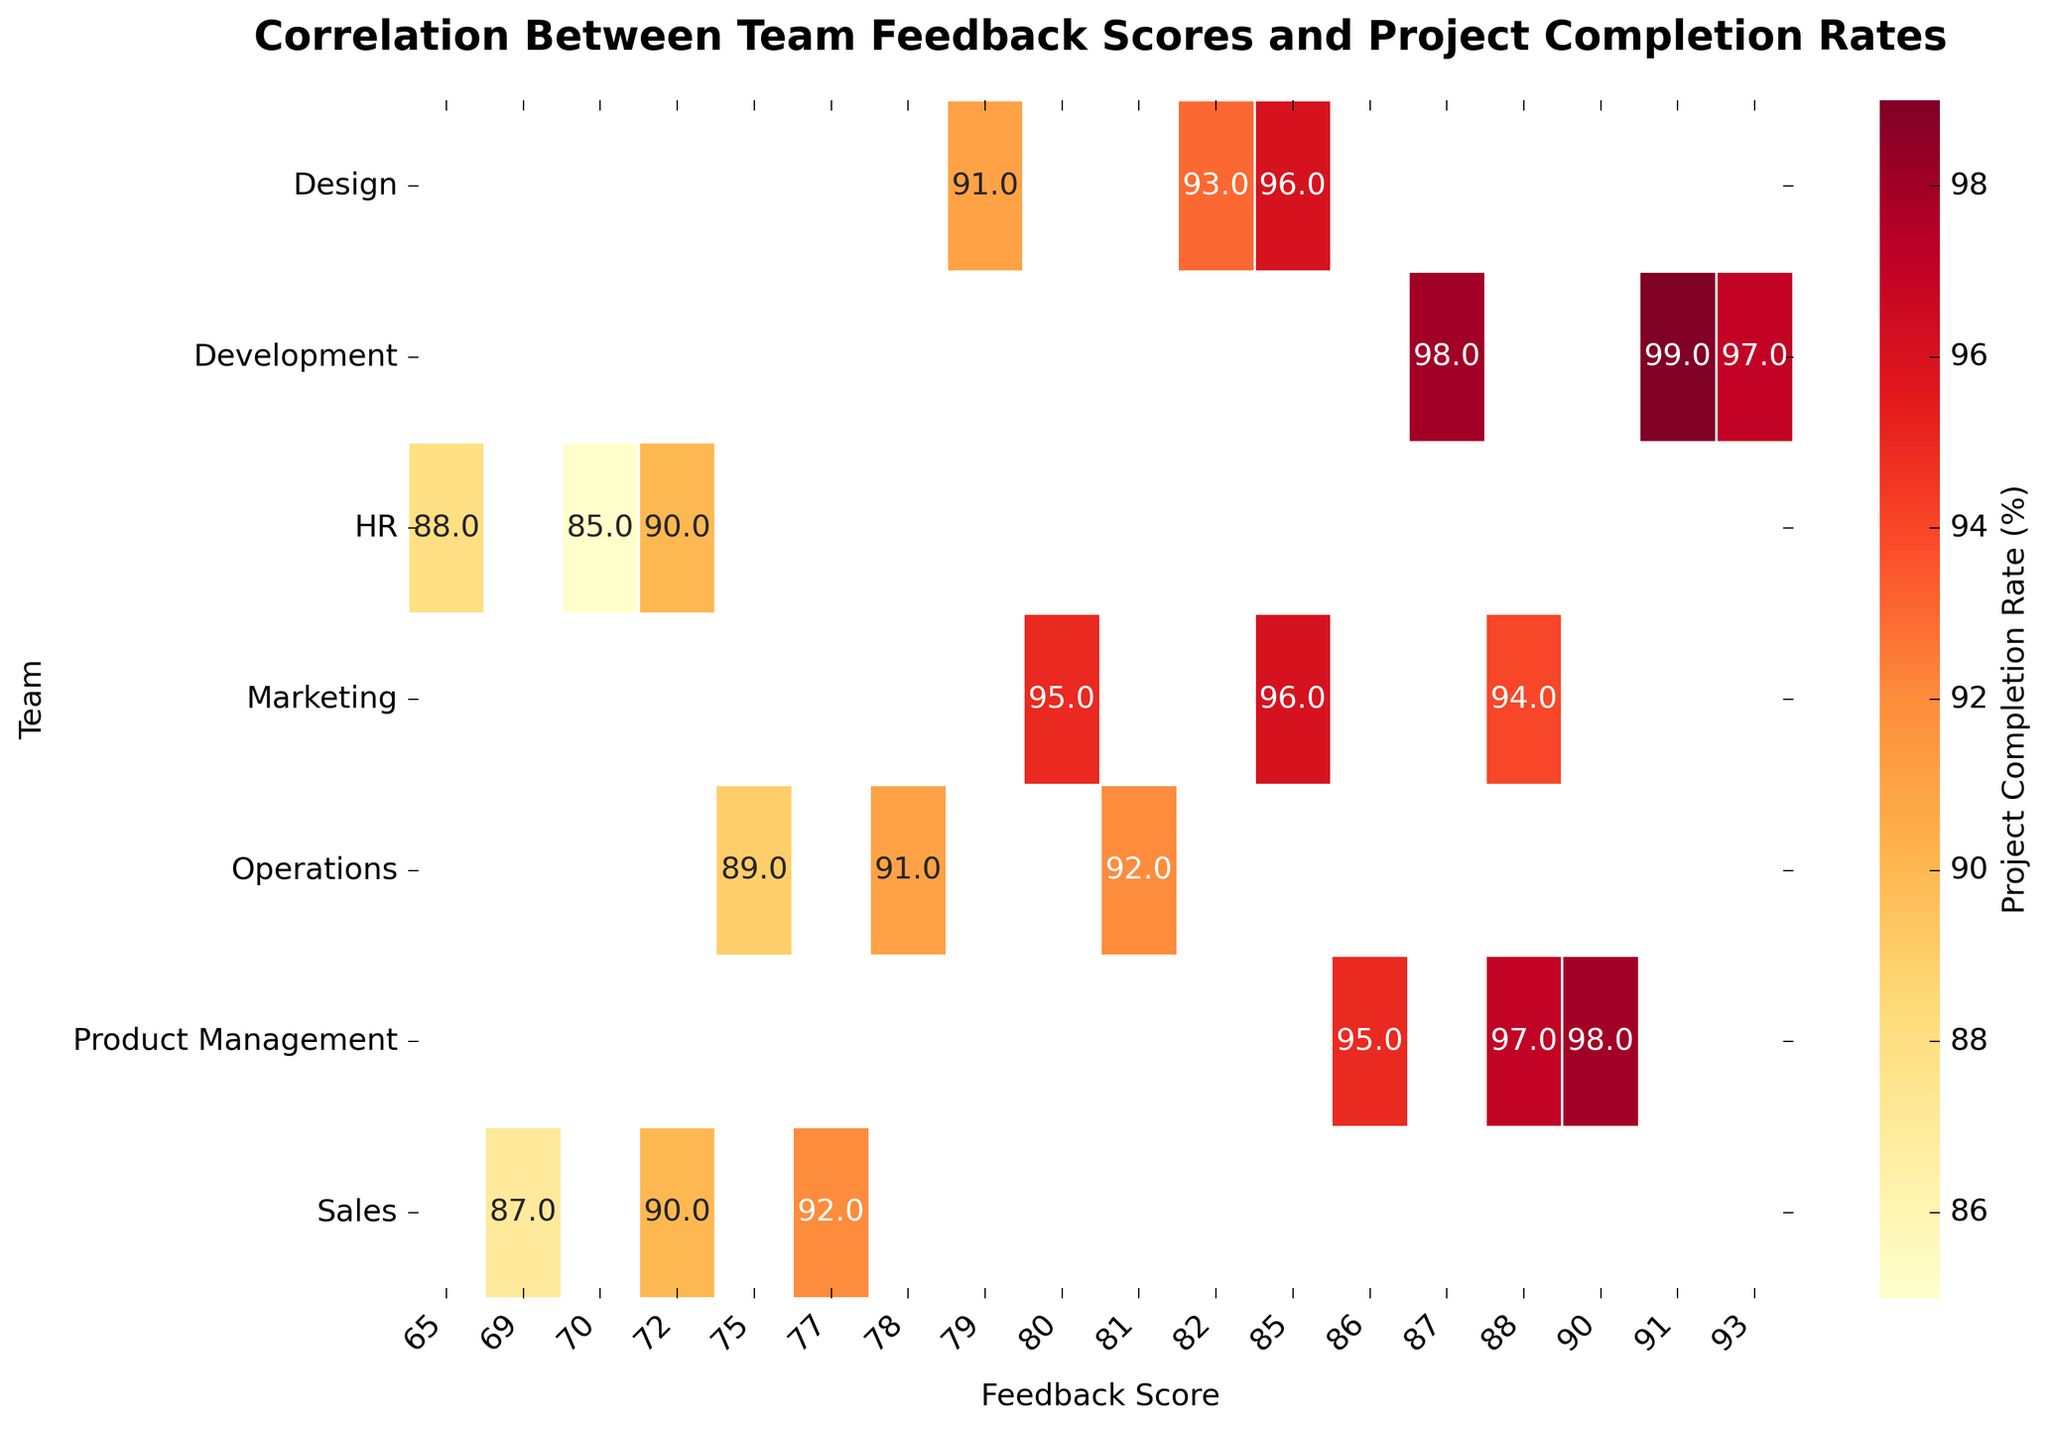What is the title of the heatmap? The title is displayed at the top of the figure in bold font.
Answer: Correlation Between Team Feedback Scores and Project Completion Rates What team has the highest project completion rate for a feedback score of 91? By scanning the row corresponding to Development and the column for Feedback_Score 91, we can see the highest completion rate value.
Answer: Development Which team has the lowest project completion rate for a feedback score of 70? By finding the intersecting cell for the HR row and Feedback_Score 70 column, we identify the lowest rate.
Answer: HR Within the Sales team, how do completion rates vary when feedback scores increase from 69 to 77? Comparing the cells for the Sales row in the columns for Feedback_Score 69, 72, and 77, we see they increase sequentially.
Answer: They increase (87 to 90 to 92) What is the average project completion rate for the Marketing team? Add the completion rates for Marketing (95, 94, and 96) and divide by the number of entries. (95+94+96)/3 = 95
Answer: 95 Compare the project completion rates between the Development and Product Management teams for feedback scores of 88. Check the intersecting cells for both teams in the column for Feedback_Score 88. Development: 98, Product Management: 97
Answer: Development is higher What feedback scores in the Operations team yield a completion rate of 91? Find all the cells in the Operations row that have the value 91.
Answer: Feedback_Scores 78 and 81 How many unique feedback scores are there in the heatmap? Count the number of unique values in the Feedback_Score column. By inspection of the x-axis labels, we notice the unique scores listed.
Answer: 11 Do higher feedback scores generally correlate with higher project completion rates across all teams? Examine the trend of project completion rates as feedback scores increase for each team. Generally, higher feedback scores result in higher completion rates.
Answer: Yes What is the overall trend observed in the heatmap? The heatmap shows that higher feedback scores are generally associated with higher project completion rates across different teams, indicating a positive correlation.
Answer: Positive correlation 